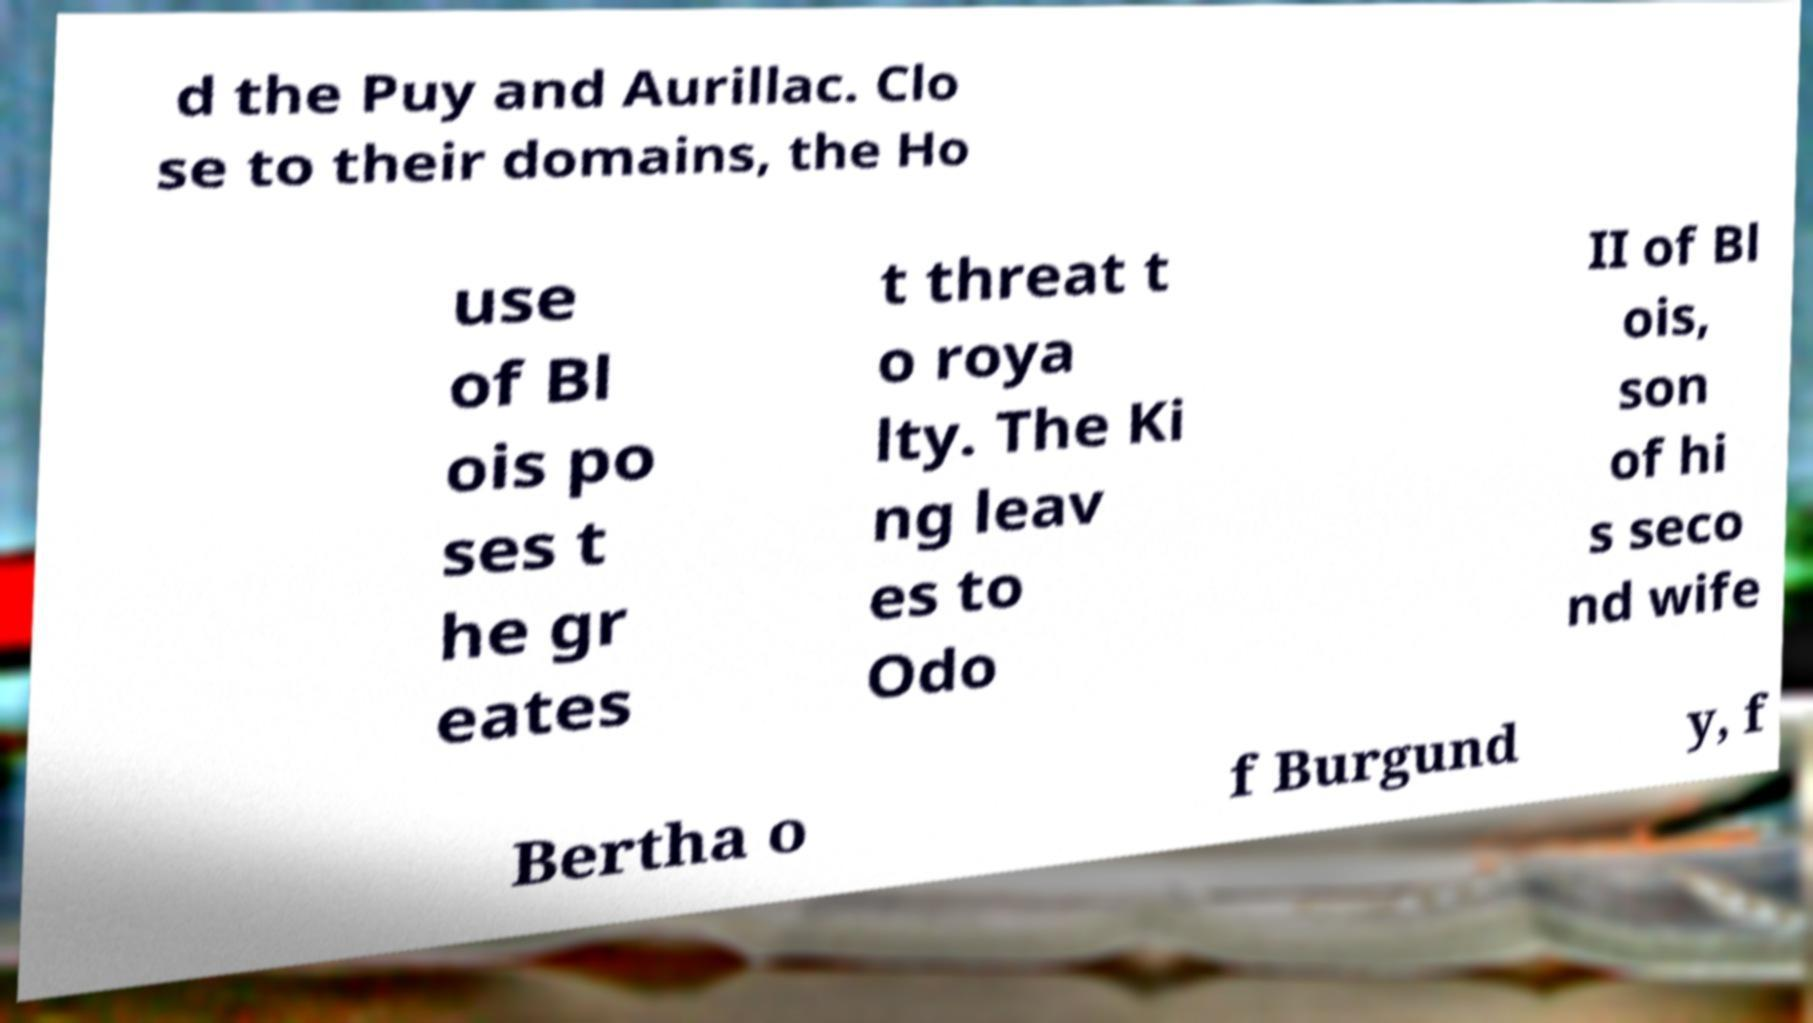Could you assist in decoding the text presented in this image and type it out clearly? d the Puy and Aurillac. Clo se to their domains, the Ho use of Bl ois po ses t he gr eates t threat t o roya lty. The Ki ng leav es to Odo II of Bl ois, son of hi s seco nd wife Bertha o f Burgund y, f 